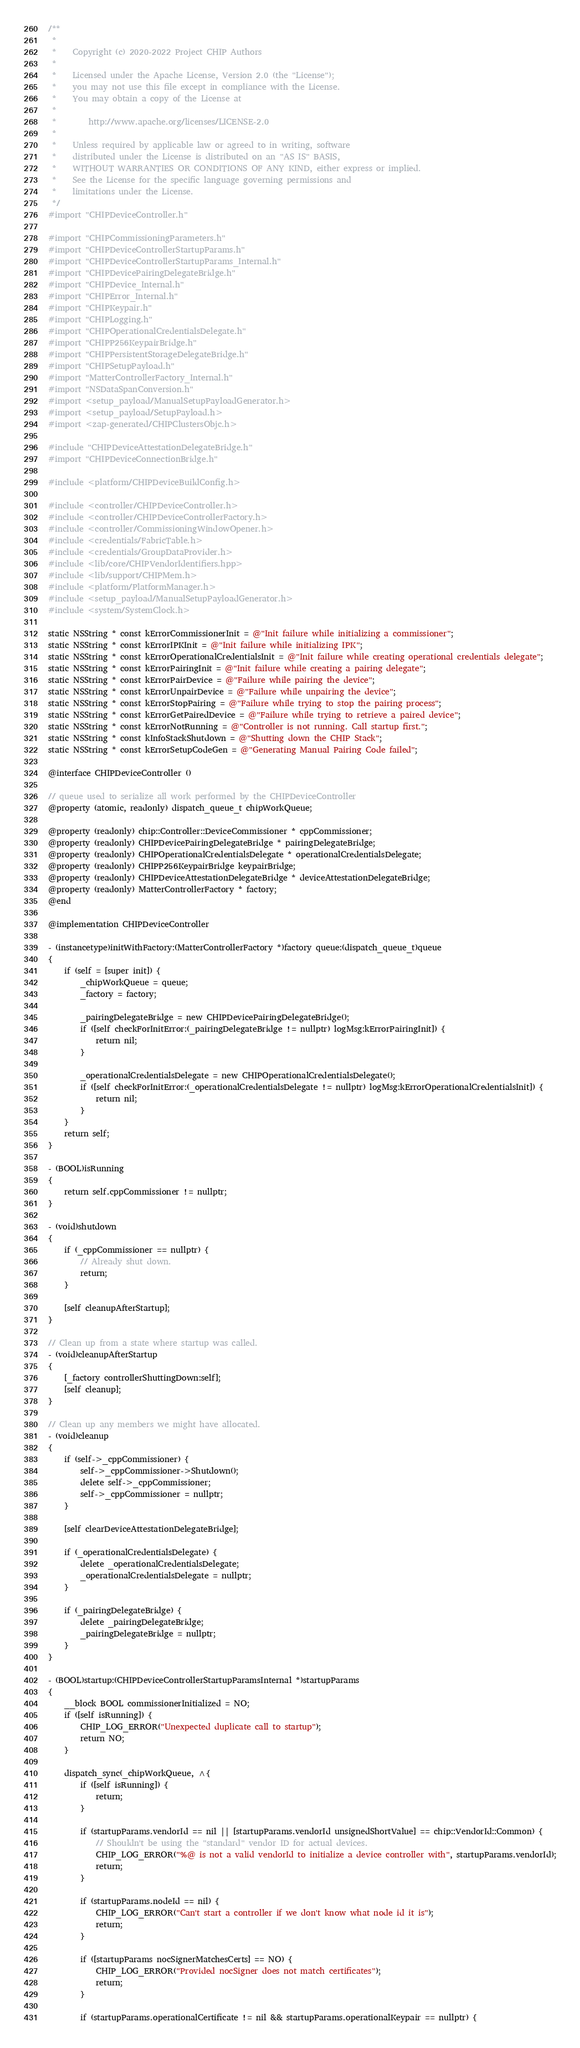<code> <loc_0><loc_0><loc_500><loc_500><_ObjectiveC_>/**
 *
 *    Copyright (c) 2020-2022 Project CHIP Authors
 *
 *    Licensed under the Apache License, Version 2.0 (the "License");
 *    you may not use this file except in compliance with the License.
 *    You may obtain a copy of the License at
 *
 *        http://www.apache.org/licenses/LICENSE-2.0
 *
 *    Unless required by applicable law or agreed to in writing, software
 *    distributed under the License is distributed on an "AS IS" BASIS,
 *    WITHOUT WARRANTIES OR CONDITIONS OF ANY KIND, either express or implied.
 *    See the License for the specific language governing permissions and
 *    limitations under the License.
 */
#import "CHIPDeviceController.h"

#import "CHIPCommissioningParameters.h"
#import "CHIPDeviceControllerStartupParams.h"
#import "CHIPDeviceControllerStartupParams_Internal.h"
#import "CHIPDevicePairingDelegateBridge.h"
#import "CHIPDevice_Internal.h"
#import "CHIPError_Internal.h"
#import "CHIPKeypair.h"
#import "CHIPLogging.h"
#import "CHIPOperationalCredentialsDelegate.h"
#import "CHIPP256KeypairBridge.h"
#import "CHIPPersistentStorageDelegateBridge.h"
#import "CHIPSetupPayload.h"
#import "MatterControllerFactory_Internal.h"
#import "NSDataSpanConversion.h"
#import <setup_payload/ManualSetupPayloadGenerator.h>
#import <setup_payload/SetupPayload.h>
#import <zap-generated/CHIPClustersObjc.h>

#include "CHIPDeviceAttestationDelegateBridge.h"
#import "CHIPDeviceConnectionBridge.h"

#include <platform/CHIPDeviceBuildConfig.h>

#include <controller/CHIPDeviceController.h>
#include <controller/CHIPDeviceControllerFactory.h>
#include <controller/CommissioningWindowOpener.h>
#include <credentials/FabricTable.h>
#include <credentials/GroupDataProvider.h>
#include <lib/core/CHIPVendorIdentifiers.hpp>
#include <lib/support/CHIPMem.h>
#include <platform/PlatformManager.h>
#include <setup_payload/ManualSetupPayloadGenerator.h>
#include <system/SystemClock.h>

static NSString * const kErrorCommissionerInit = @"Init failure while initializing a commissioner";
static NSString * const kErrorIPKInit = @"Init failure while initializing IPK";
static NSString * const kErrorOperationalCredentialsInit = @"Init failure while creating operational credentials delegate";
static NSString * const kErrorPairingInit = @"Init failure while creating a pairing delegate";
static NSString * const kErrorPairDevice = @"Failure while pairing the device";
static NSString * const kErrorUnpairDevice = @"Failure while unpairing the device";
static NSString * const kErrorStopPairing = @"Failure while trying to stop the pairing process";
static NSString * const kErrorGetPairedDevice = @"Failure while trying to retrieve a paired device";
static NSString * const kErrorNotRunning = @"Controller is not running. Call startup first.";
static NSString * const kInfoStackShutdown = @"Shutting down the CHIP Stack";
static NSString * const kErrorSetupCodeGen = @"Generating Manual Pairing Code failed";

@interface CHIPDeviceController ()

// queue used to serialize all work performed by the CHIPDeviceController
@property (atomic, readonly) dispatch_queue_t chipWorkQueue;

@property (readonly) chip::Controller::DeviceCommissioner * cppCommissioner;
@property (readonly) CHIPDevicePairingDelegateBridge * pairingDelegateBridge;
@property (readonly) CHIPOperationalCredentialsDelegate * operationalCredentialsDelegate;
@property (readonly) CHIPP256KeypairBridge keypairBridge;
@property (readonly) CHIPDeviceAttestationDelegateBridge * deviceAttestationDelegateBridge;
@property (readonly) MatterControllerFactory * factory;
@end

@implementation CHIPDeviceController

- (instancetype)initWithFactory:(MatterControllerFactory *)factory queue:(dispatch_queue_t)queue
{
    if (self = [super init]) {
        _chipWorkQueue = queue;
        _factory = factory;

        _pairingDelegateBridge = new CHIPDevicePairingDelegateBridge();
        if ([self checkForInitError:(_pairingDelegateBridge != nullptr) logMsg:kErrorPairingInit]) {
            return nil;
        }

        _operationalCredentialsDelegate = new CHIPOperationalCredentialsDelegate();
        if ([self checkForInitError:(_operationalCredentialsDelegate != nullptr) logMsg:kErrorOperationalCredentialsInit]) {
            return nil;
        }
    }
    return self;
}

- (BOOL)isRunning
{
    return self.cppCommissioner != nullptr;
}

- (void)shutdown
{
    if (_cppCommissioner == nullptr) {
        // Already shut down.
        return;
    }

    [self cleanupAfterStartup];
}

// Clean up from a state where startup was called.
- (void)cleanupAfterStartup
{
    [_factory controllerShuttingDown:self];
    [self cleanup];
}

// Clean up any members we might have allocated.
- (void)cleanup
{
    if (self->_cppCommissioner) {
        self->_cppCommissioner->Shutdown();
        delete self->_cppCommissioner;
        self->_cppCommissioner = nullptr;
    }

    [self clearDeviceAttestationDelegateBridge];

    if (_operationalCredentialsDelegate) {
        delete _operationalCredentialsDelegate;
        _operationalCredentialsDelegate = nullptr;
    }

    if (_pairingDelegateBridge) {
        delete _pairingDelegateBridge;
        _pairingDelegateBridge = nullptr;
    }
}

- (BOOL)startup:(CHIPDeviceControllerStartupParamsInternal *)startupParams
{
    __block BOOL commissionerInitialized = NO;
    if ([self isRunning]) {
        CHIP_LOG_ERROR("Unexpected duplicate call to startup");
        return NO;
    }

    dispatch_sync(_chipWorkQueue, ^{
        if ([self isRunning]) {
            return;
        }

        if (startupParams.vendorId == nil || [startupParams.vendorId unsignedShortValue] == chip::VendorId::Common) {
            // Shouldn't be using the "standard" vendor ID for actual devices.
            CHIP_LOG_ERROR("%@ is not a valid vendorId to initialize a device controller with", startupParams.vendorId);
            return;
        }

        if (startupParams.nodeId == nil) {
            CHIP_LOG_ERROR("Can't start a controller if we don't know what node id it is");
            return;
        }

        if ([startupParams nocSignerMatchesCerts] == NO) {
            CHIP_LOG_ERROR("Provided nocSigner does not match certificates");
            return;
        }

        if (startupParams.operationalCertificate != nil && startupParams.operationalKeypair == nullptr) {</code> 